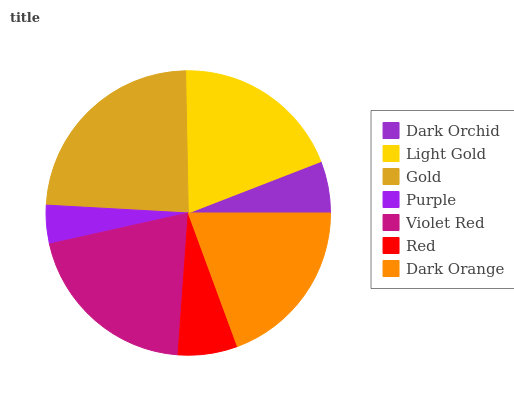Is Purple the minimum?
Answer yes or no. Yes. Is Gold the maximum?
Answer yes or no. Yes. Is Light Gold the minimum?
Answer yes or no. No. Is Light Gold the maximum?
Answer yes or no. No. Is Light Gold greater than Dark Orchid?
Answer yes or no. Yes. Is Dark Orchid less than Light Gold?
Answer yes or no. Yes. Is Dark Orchid greater than Light Gold?
Answer yes or no. No. Is Light Gold less than Dark Orchid?
Answer yes or no. No. Is Dark Orange the high median?
Answer yes or no. Yes. Is Dark Orange the low median?
Answer yes or no. Yes. Is Dark Orchid the high median?
Answer yes or no. No. Is Gold the low median?
Answer yes or no. No. 